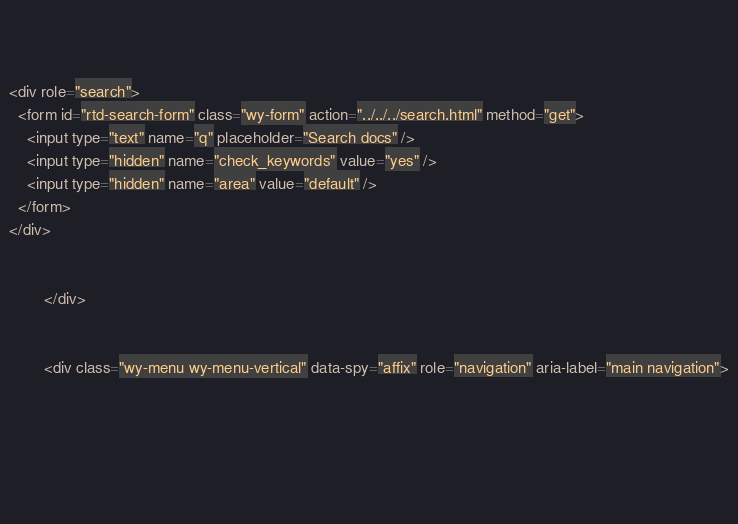<code> <loc_0><loc_0><loc_500><loc_500><_HTML_>          

          
<div role="search">
  <form id="rtd-search-form" class="wy-form" action="../../../search.html" method="get">
    <input type="text" name="q" placeholder="Search docs" />
    <input type="hidden" name="check_keywords" value="yes" />
    <input type="hidden" name="area" value="default" />
  </form>
</div>

          
        </div>

        
        <div class="wy-menu wy-menu-vertical" data-spy="affix" role="navigation" aria-label="main navigation">
          
            
            
              
            
            </code> 